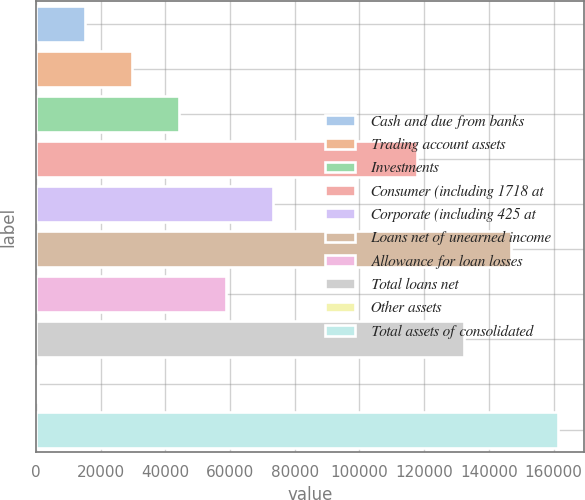<chart> <loc_0><loc_0><loc_500><loc_500><bar_chart><fcel>Cash and due from banks<fcel>Trading account assets<fcel>Investments<fcel>Consumer (including 1718 at<fcel>Corporate (including 425 at<fcel>Loans net of unearned income<fcel>Allowance for loan losses<fcel>Total loans net<fcel>Other assets<fcel>Total assets of consolidated<nl><fcel>15201.3<fcel>29722.6<fcel>44243.9<fcel>117768<fcel>73286.5<fcel>146811<fcel>58765.2<fcel>132289<fcel>680<fcel>161332<nl></chart> 